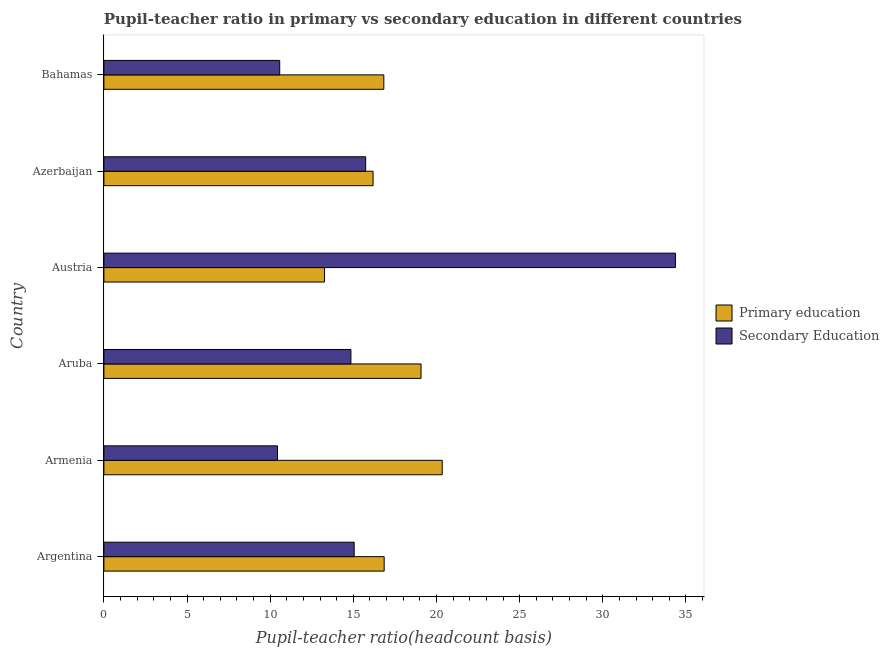How many different coloured bars are there?
Offer a terse response. 2. How many groups of bars are there?
Offer a terse response. 6. How many bars are there on the 2nd tick from the top?
Provide a short and direct response. 2. What is the label of the 1st group of bars from the top?
Make the answer very short. Bahamas. What is the pupil teacher ratio on secondary education in Bahamas?
Provide a short and direct response. 10.57. Across all countries, what is the maximum pupil teacher ratio on secondary education?
Provide a succinct answer. 34.37. Across all countries, what is the minimum pupil-teacher ratio in primary education?
Offer a terse response. 13.27. In which country was the pupil-teacher ratio in primary education maximum?
Keep it short and to the point. Armenia. In which country was the pupil teacher ratio on secondary education minimum?
Provide a short and direct response. Armenia. What is the total pupil-teacher ratio in primary education in the graph?
Give a very brief answer. 102.55. What is the difference between the pupil teacher ratio on secondary education in Aruba and that in Austria?
Offer a very short reply. -19.51. What is the difference between the pupil-teacher ratio in primary education in Austria and the pupil teacher ratio on secondary education in Bahamas?
Your answer should be very brief. 2.7. What is the average pupil-teacher ratio in primary education per country?
Keep it short and to the point. 17.09. What is the difference between the pupil teacher ratio on secondary education and pupil-teacher ratio in primary education in Argentina?
Your response must be concise. -1.8. In how many countries, is the pupil-teacher ratio in primary education greater than 24 ?
Offer a terse response. 0. What is the ratio of the pupil-teacher ratio in primary education in Aruba to that in Bahamas?
Your answer should be compact. 1.13. What is the difference between the highest and the second highest pupil-teacher ratio in primary education?
Give a very brief answer. 1.27. What is the difference between the highest and the lowest pupil teacher ratio on secondary education?
Offer a very short reply. 23.93. In how many countries, is the pupil teacher ratio on secondary education greater than the average pupil teacher ratio on secondary education taken over all countries?
Your response must be concise. 1. Is the sum of the pupil-teacher ratio in primary education in Aruba and Azerbaijan greater than the maximum pupil teacher ratio on secondary education across all countries?
Provide a short and direct response. Yes. What does the 1st bar from the top in Aruba represents?
Make the answer very short. Secondary Education. What does the 2nd bar from the bottom in Bahamas represents?
Your answer should be very brief. Secondary Education. How many countries are there in the graph?
Provide a succinct answer. 6. What is the difference between two consecutive major ticks on the X-axis?
Ensure brevity in your answer.  5. Does the graph contain grids?
Your answer should be very brief. No. Where does the legend appear in the graph?
Your answer should be very brief. Center right. How many legend labels are there?
Keep it short and to the point. 2. How are the legend labels stacked?
Give a very brief answer. Vertical. What is the title of the graph?
Provide a succinct answer. Pupil-teacher ratio in primary vs secondary education in different countries. Does "Male population" appear as one of the legend labels in the graph?
Your answer should be very brief. No. What is the label or title of the X-axis?
Offer a terse response. Pupil-teacher ratio(headcount basis). What is the label or title of the Y-axis?
Your answer should be very brief. Country. What is the Pupil-teacher ratio(headcount basis) in Primary education in Argentina?
Provide a succinct answer. 16.85. What is the Pupil-teacher ratio(headcount basis) in Secondary Education in Argentina?
Give a very brief answer. 15.05. What is the Pupil-teacher ratio(headcount basis) in Primary education in Armenia?
Offer a terse response. 20.34. What is the Pupil-teacher ratio(headcount basis) of Secondary Education in Armenia?
Provide a short and direct response. 10.44. What is the Pupil-teacher ratio(headcount basis) in Primary education in Aruba?
Keep it short and to the point. 19.07. What is the Pupil-teacher ratio(headcount basis) of Secondary Education in Aruba?
Give a very brief answer. 14.85. What is the Pupil-teacher ratio(headcount basis) in Primary education in Austria?
Offer a very short reply. 13.27. What is the Pupil-teacher ratio(headcount basis) of Secondary Education in Austria?
Your answer should be compact. 34.37. What is the Pupil-teacher ratio(headcount basis) in Primary education in Azerbaijan?
Offer a very short reply. 16.19. What is the Pupil-teacher ratio(headcount basis) in Secondary Education in Azerbaijan?
Make the answer very short. 15.74. What is the Pupil-teacher ratio(headcount basis) of Primary education in Bahamas?
Give a very brief answer. 16.83. What is the Pupil-teacher ratio(headcount basis) of Secondary Education in Bahamas?
Make the answer very short. 10.57. Across all countries, what is the maximum Pupil-teacher ratio(headcount basis) in Primary education?
Offer a very short reply. 20.34. Across all countries, what is the maximum Pupil-teacher ratio(headcount basis) of Secondary Education?
Provide a short and direct response. 34.37. Across all countries, what is the minimum Pupil-teacher ratio(headcount basis) of Primary education?
Offer a terse response. 13.27. Across all countries, what is the minimum Pupil-teacher ratio(headcount basis) of Secondary Education?
Your response must be concise. 10.44. What is the total Pupil-teacher ratio(headcount basis) in Primary education in the graph?
Provide a succinct answer. 102.55. What is the total Pupil-teacher ratio(headcount basis) of Secondary Education in the graph?
Your response must be concise. 101.02. What is the difference between the Pupil-teacher ratio(headcount basis) of Primary education in Argentina and that in Armenia?
Offer a very short reply. -3.49. What is the difference between the Pupil-teacher ratio(headcount basis) in Secondary Education in Argentina and that in Armenia?
Offer a terse response. 4.61. What is the difference between the Pupil-teacher ratio(headcount basis) in Primary education in Argentina and that in Aruba?
Offer a very short reply. -2.22. What is the difference between the Pupil-teacher ratio(headcount basis) in Secondary Education in Argentina and that in Aruba?
Your response must be concise. 0.2. What is the difference between the Pupil-teacher ratio(headcount basis) in Primary education in Argentina and that in Austria?
Give a very brief answer. 3.59. What is the difference between the Pupil-teacher ratio(headcount basis) in Secondary Education in Argentina and that in Austria?
Your answer should be compact. -19.32. What is the difference between the Pupil-teacher ratio(headcount basis) of Primary education in Argentina and that in Azerbaijan?
Provide a succinct answer. 0.67. What is the difference between the Pupil-teacher ratio(headcount basis) in Secondary Education in Argentina and that in Azerbaijan?
Your response must be concise. -0.69. What is the difference between the Pupil-teacher ratio(headcount basis) of Primary education in Argentina and that in Bahamas?
Provide a short and direct response. 0.02. What is the difference between the Pupil-teacher ratio(headcount basis) of Secondary Education in Argentina and that in Bahamas?
Make the answer very short. 4.48. What is the difference between the Pupil-teacher ratio(headcount basis) in Primary education in Armenia and that in Aruba?
Offer a terse response. 1.27. What is the difference between the Pupil-teacher ratio(headcount basis) in Secondary Education in Armenia and that in Aruba?
Give a very brief answer. -4.42. What is the difference between the Pupil-teacher ratio(headcount basis) in Primary education in Armenia and that in Austria?
Give a very brief answer. 7.08. What is the difference between the Pupil-teacher ratio(headcount basis) in Secondary Education in Armenia and that in Austria?
Your response must be concise. -23.93. What is the difference between the Pupil-teacher ratio(headcount basis) of Primary education in Armenia and that in Azerbaijan?
Ensure brevity in your answer.  4.16. What is the difference between the Pupil-teacher ratio(headcount basis) in Secondary Education in Armenia and that in Azerbaijan?
Your answer should be compact. -5.3. What is the difference between the Pupil-teacher ratio(headcount basis) in Primary education in Armenia and that in Bahamas?
Provide a succinct answer. 3.51. What is the difference between the Pupil-teacher ratio(headcount basis) in Secondary Education in Armenia and that in Bahamas?
Your answer should be compact. -0.13. What is the difference between the Pupil-teacher ratio(headcount basis) of Primary education in Aruba and that in Austria?
Offer a very short reply. 5.8. What is the difference between the Pupil-teacher ratio(headcount basis) of Secondary Education in Aruba and that in Austria?
Ensure brevity in your answer.  -19.51. What is the difference between the Pupil-teacher ratio(headcount basis) of Primary education in Aruba and that in Azerbaijan?
Your response must be concise. 2.88. What is the difference between the Pupil-teacher ratio(headcount basis) of Secondary Education in Aruba and that in Azerbaijan?
Make the answer very short. -0.89. What is the difference between the Pupil-teacher ratio(headcount basis) of Primary education in Aruba and that in Bahamas?
Ensure brevity in your answer.  2.24. What is the difference between the Pupil-teacher ratio(headcount basis) of Secondary Education in Aruba and that in Bahamas?
Your response must be concise. 4.28. What is the difference between the Pupil-teacher ratio(headcount basis) of Primary education in Austria and that in Azerbaijan?
Your answer should be compact. -2.92. What is the difference between the Pupil-teacher ratio(headcount basis) in Secondary Education in Austria and that in Azerbaijan?
Make the answer very short. 18.63. What is the difference between the Pupil-teacher ratio(headcount basis) of Primary education in Austria and that in Bahamas?
Keep it short and to the point. -3.56. What is the difference between the Pupil-teacher ratio(headcount basis) in Secondary Education in Austria and that in Bahamas?
Provide a succinct answer. 23.8. What is the difference between the Pupil-teacher ratio(headcount basis) of Primary education in Azerbaijan and that in Bahamas?
Offer a terse response. -0.65. What is the difference between the Pupil-teacher ratio(headcount basis) of Secondary Education in Azerbaijan and that in Bahamas?
Your answer should be very brief. 5.17. What is the difference between the Pupil-teacher ratio(headcount basis) in Primary education in Argentina and the Pupil-teacher ratio(headcount basis) in Secondary Education in Armenia?
Ensure brevity in your answer.  6.42. What is the difference between the Pupil-teacher ratio(headcount basis) of Primary education in Argentina and the Pupil-teacher ratio(headcount basis) of Secondary Education in Aruba?
Give a very brief answer. 2. What is the difference between the Pupil-teacher ratio(headcount basis) in Primary education in Argentina and the Pupil-teacher ratio(headcount basis) in Secondary Education in Austria?
Make the answer very short. -17.51. What is the difference between the Pupil-teacher ratio(headcount basis) in Primary education in Argentina and the Pupil-teacher ratio(headcount basis) in Secondary Education in Azerbaijan?
Provide a short and direct response. 1.11. What is the difference between the Pupil-teacher ratio(headcount basis) in Primary education in Argentina and the Pupil-teacher ratio(headcount basis) in Secondary Education in Bahamas?
Your answer should be very brief. 6.28. What is the difference between the Pupil-teacher ratio(headcount basis) of Primary education in Armenia and the Pupil-teacher ratio(headcount basis) of Secondary Education in Aruba?
Offer a very short reply. 5.49. What is the difference between the Pupil-teacher ratio(headcount basis) of Primary education in Armenia and the Pupil-teacher ratio(headcount basis) of Secondary Education in Austria?
Provide a succinct answer. -14.02. What is the difference between the Pupil-teacher ratio(headcount basis) of Primary education in Armenia and the Pupil-teacher ratio(headcount basis) of Secondary Education in Azerbaijan?
Ensure brevity in your answer.  4.6. What is the difference between the Pupil-teacher ratio(headcount basis) of Primary education in Armenia and the Pupil-teacher ratio(headcount basis) of Secondary Education in Bahamas?
Provide a succinct answer. 9.77. What is the difference between the Pupil-teacher ratio(headcount basis) of Primary education in Aruba and the Pupil-teacher ratio(headcount basis) of Secondary Education in Austria?
Your answer should be compact. -15.3. What is the difference between the Pupil-teacher ratio(headcount basis) in Primary education in Aruba and the Pupil-teacher ratio(headcount basis) in Secondary Education in Azerbaijan?
Give a very brief answer. 3.33. What is the difference between the Pupil-teacher ratio(headcount basis) of Primary education in Aruba and the Pupil-teacher ratio(headcount basis) of Secondary Education in Bahamas?
Ensure brevity in your answer.  8.5. What is the difference between the Pupil-teacher ratio(headcount basis) in Primary education in Austria and the Pupil-teacher ratio(headcount basis) in Secondary Education in Azerbaijan?
Offer a terse response. -2.47. What is the difference between the Pupil-teacher ratio(headcount basis) in Primary education in Austria and the Pupil-teacher ratio(headcount basis) in Secondary Education in Bahamas?
Your answer should be very brief. 2.7. What is the difference between the Pupil-teacher ratio(headcount basis) in Primary education in Azerbaijan and the Pupil-teacher ratio(headcount basis) in Secondary Education in Bahamas?
Make the answer very short. 5.61. What is the average Pupil-teacher ratio(headcount basis) of Primary education per country?
Keep it short and to the point. 17.09. What is the average Pupil-teacher ratio(headcount basis) in Secondary Education per country?
Make the answer very short. 16.84. What is the difference between the Pupil-teacher ratio(headcount basis) of Primary education and Pupil-teacher ratio(headcount basis) of Secondary Education in Argentina?
Your answer should be compact. 1.8. What is the difference between the Pupil-teacher ratio(headcount basis) in Primary education and Pupil-teacher ratio(headcount basis) in Secondary Education in Armenia?
Make the answer very short. 9.91. What is the difference between the Pupil-teacher ratio(headcount basis) in Primary education and Pupil-teacher ratio(headcount basis) in Secondary Education in Aruba?
Keep it short and to the point. 4.22. What is the difference between the Pupil-teacher ratio(headcount basis) in Primary education and Pupil-teacher ratio(headcount basis) in Secondary Education in Austria?
Make the answer very short. -21.1. What is the difference between the Pupil-teacher ratio(headcount basis) in Primary education and Pupil-teacher ratio(headcount basis) in Secondary Education in Azerbaijan?
Offer a terse response. 0.44. What is the difference between the Pupil-teacher ratio(headcount basis) of Primary education and Pupil-teacher ratio(headcount basis) of Secondary Education in Bahamas?
Keep it short and to the point. 6.26. What is the ratio of the Pupil-teacher ratio(headcount basis) in Primary education in Argentina to that in Armenia?
Give a very brief answer. 0.83. What is the ratio of the Pupil-teacher ratio(headcount basis) in Secondary Education in Argentina to that in Armenia?
Ensure brevity in your answer.  1.44. What is the ratio of the Pupil-teacher ratio(headcount basis) of Primary education in Argentina to that in Aruba?
Your response must be concise. 0.88. What is the ratio of the Pupil-teacher ratio(headcount basis) in Secondary Education in Argentina to that in Aruba?
Provide a succinct answer. 1.01. What is the ratio of the Pupil-teacher ratio(headcount basis) in Primary education in Argentina to that in Austria?
Your answer should be compact. 1.27. What is the ratio of the Pupil-teacher ratio(headcount basis) of Secondary Education in Argentina to that in Austria?
Provide a short and direct response. 0.44. What is the ratio of the Pupil-teacher ratio(headcount basis) of Primary education in Argentina to that in Azerbaijan?
Your answer should be very brief. 1.04. What is the ratio of the Pupil-teacher ratio(headcount basis) in Secondary Education in Argentina to that in Azerbaijan?
Provide a succinct answer. 0.96. What is the ratio of the Pupil-teacher ratio(headcount basis) of Secondary Education in Argentina to that in Bahamas?
Your answer should be compact. 1.42. What is the ratio of the Pupil-teacher ratio(headcount basis) of Primary education in Armenia to that in Aruba?
Ensure brevity in your answer.  1.07. What is the ratio of the Pupil-teacher ratio(headcount basis) in Secondary Education in Armenia to that in Aruba?
Your response must be concise. 0.7. What is the ratio of the Pupil-teacher ratio(headcount basis) of Primary education in Armenia to that in Austria?
Offer a very short reply. 1.53. What is the ratio of the Pupil-teacher ratio(headcount basis) in Secondary Education in Armenia to that in Austria?
Your response must be concise. 0.3. What is the ratio of the Pupil-teacher ratio(headcount basis) in Primary education in Armenia to that in Azerbaijan?
Ensure brevity in your answer.  1.26. What is the ratio of the Pupil-teacher ratio(headcount basis) of Secondary Education in Armenia to that in Azerbaijan?
Keep it short and to the point. 0.66. What is the ratio of the Pupil-teacher ratio(headcount basis) of Primary education in Armenia to that in Bahamas?
Your answer should be very brief. 1.21. What is the ratio of the Pupil-teacher ratio(headcount basis) in Secondary Education in Armenia to that in Bahamas?
Your answer should be compact. 0.99. What is the ratio of the Pupil-teacher ratio(headcount basis) in Primary education in Aruba to that in Austria?
Keep it short and to the point. 1.44. What is the ratio of the Pupil-teacher ratio(headcount basis) of Secondary Education in Aruba to that in Austria?
Provide a succinct answer. 0.43. What is the ratio of the Pupil-teacher ratio(headcount basis) in Primary education in Aruba to that in Azerbaijan?
Your answer should be very brief. 1.18. What is the ratio of the Pupil-teacher ratio(headcount basis) of Secondary Education in Aruba to that in Azerbaijan?
Your answer should be compact. 0.94. What is the ratio of the Pupil-teacher ratio(headcount basis) in Primary education in Aruba to that in Bahamas?
Your answer should be compact. 1.13. What is the ratio of the Pupil-teacher ratio(headcount basis) in Secondary Education in Aruba to that in Bahamas?
Make the answer very short. 1.41. What is the ratio of the Pupil-teacher ratio(headcount basis) in Primary education in Austria to that in Azerbaijan?
Your answer should be compact. 0.82. What is the ratio of the Pupil-teacher ratio(headcount basis) of Secondary Education in Austria to that in Azerbaijan?
Give a very brief answer. 2.18. What is the ratio of the Pupil-teacher ratio(headcount basis) of Primary education in Austria to that in Bahamas?
Your answer should be compact. 0.79. What is the ratio of the Pupil-teacher ratio(headcount basis) in Secondary Education in Austria to that in Bahamas?
Keep it short and to the point. 3.25. What is the ratio of the Pupil-teacher ratio(headcount basis) in Primary education in Azerbaijan to that in Bahamas?
Your answer should be compact. 0.96. What is the ratio of the Pupil-teacher ratio(headcount basis) in Secondary Education in Azerbaijan to that in Bahamas?
Keep it short and to the point. 1.49. What is the difference between the highest and the second highest Pupil-teacher ratio(headcount basis) in Primary education?
Your answer should be very brief. 1.27. What is the difference between the highest and the second highest Pupil-teacher ratio(headcount basis) in Secondary Education?
Provide a short and direct response. 18.63. What is the difference between the highest and the lowest Pupil-teacher ratio(headcount basis) of Primary education?
Keep it short and to the point. 7.08. What is the difference between the highest and the lowest Pupil-teacher ratio(headcount basis) of Secondary Education?
Your answer should be very brief. 23.93. 